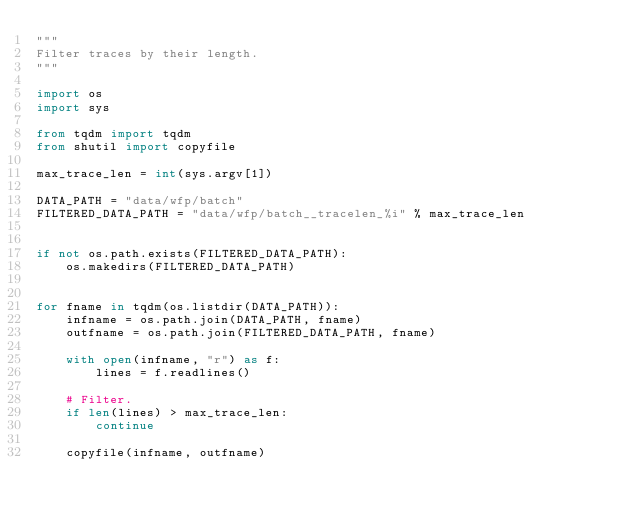Convert code to text. <code><loc_0><loc_0><loc_500><loc_500><_Python_>"""
Filter traces by their length.
"""

import os
import sys

from tqdm import tqdm
from shutil import copyfile

max_trace_len = int(sys.argv[1])

DATA_PATH = "data/wfp/batch"
FILTERED_DATA_PATH = "data/wfp/batch__tracelen_%i" % max_trace_len


if not os.path.exists(FILTERED_DATA_PATH):
    os.makedirs(FILTERED_DATA_PATH)


for fname in tqdm(os.listdir(DATA_PATH)):
    infname = os.path.join(DATA_PATH, fname)
    outfname = os.path.join(FILTERED_DATA_PATH, fname)

    with open(infname, "r") as f:
        lines = f.readlines()

    # Filter.
    if len(lines) > max_trace_len:
        continue

    copyfile(infname, outfname)
</code> 